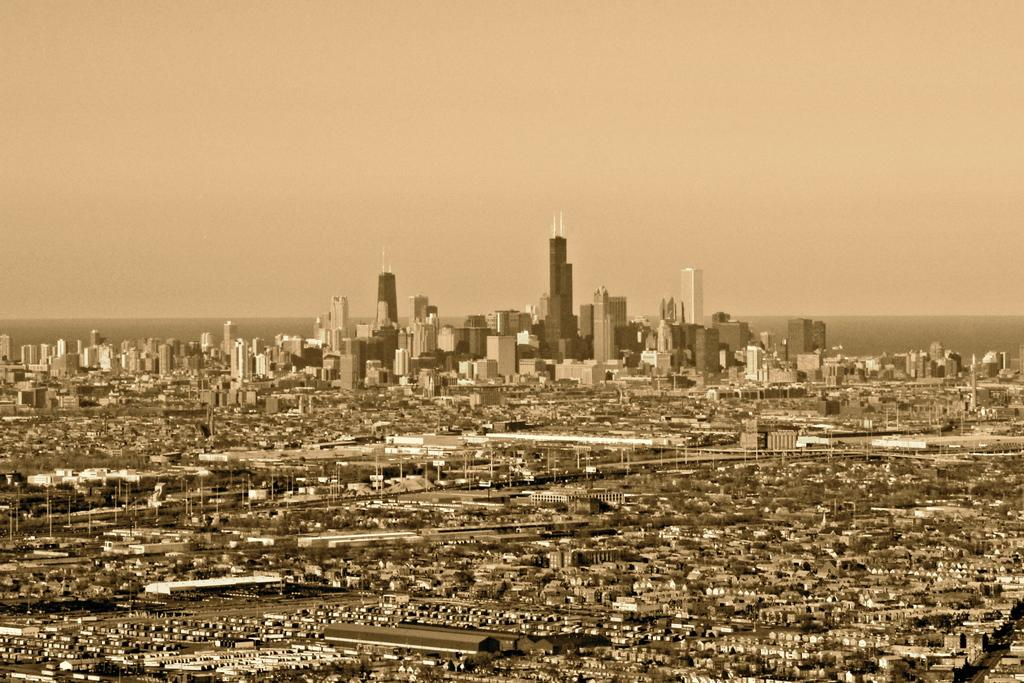What type of structures can be seen in the image? There are buildings, houses, and poles in the image. What type of vegetation is present in the image? There are trees in the image. What part of the natural environment is visible in the image? The sky is visible in the image. What type of jewel can be seen on top of the tallest building in the image? There is no jewel present on top of any building in the image. 